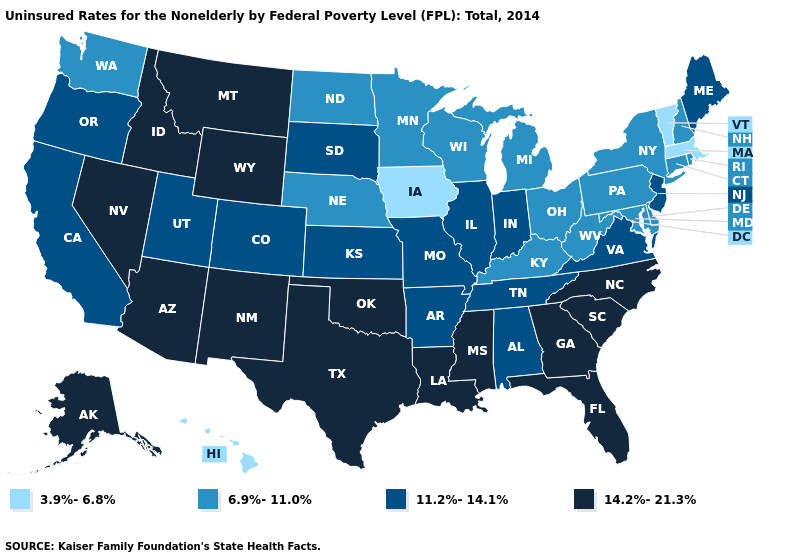Which states hav the highest value in the West?
Answer briefly. Alaska, Arizona, Idaho, Montana, Nevada, New Mexico, Wyoming. Does Hawaii have the lowest value in the West?
Give a very brief answer. Yes. What is the value of Michigan?
Give a very brief answer. 6.9%-11.0%. What is the value of New Jersey?
Write a very short answer. 11.2%-14.1%. What is the value of Rhode Island?
Write a very short answer. 6.9%-11.0%. Among the states that border Wyoming , which have the lowest value?
Write a very short answer. Nebraska. Which states have the lowest value in the USA?
Answer briefly. Hawaii, Iowa, Massachusetts, Vermont. What is the highest value in states that border West Virginia?
Concise answer only. 11.2%-14.1%. What is the value of Kansas?
Be succinct. 11.2%-14.1%. What is the value of Virginia?
Quick response, please. 11.2%-14.1%. Which states hav the highest value in the South?
Answer briefly. Florida, Georgia, Louisiana, Mississippi, North Carolina, Oklahoma, South Carolina, Texas. What is the value of Connecticut?
Answer briefly. 6.9%-11.0%. What is the highest value in the USA?
Be succinct. 14.2%-21.3%. What is the value of Idaho?
Give a very brief answer. 14.2%-21.3%. 